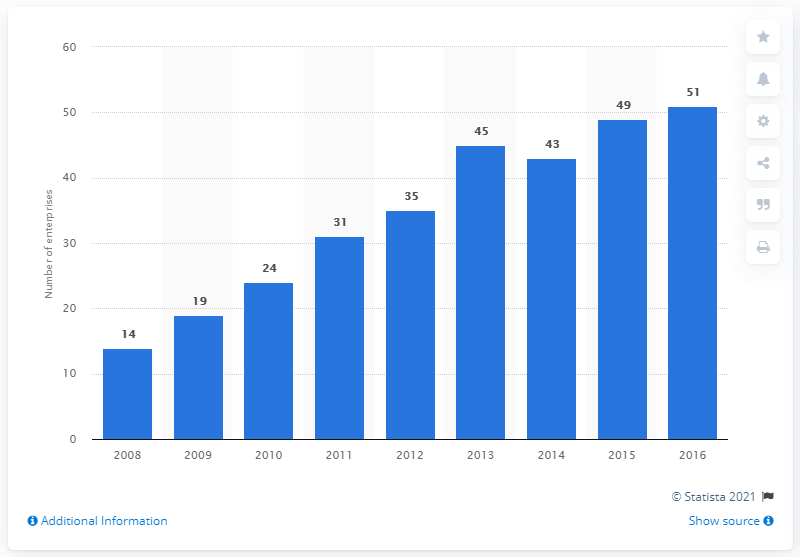Give some essential details in this illustration. In 2015, there were 49 enterprises in Latvia that manufactured perfumes and toilet preparations. 